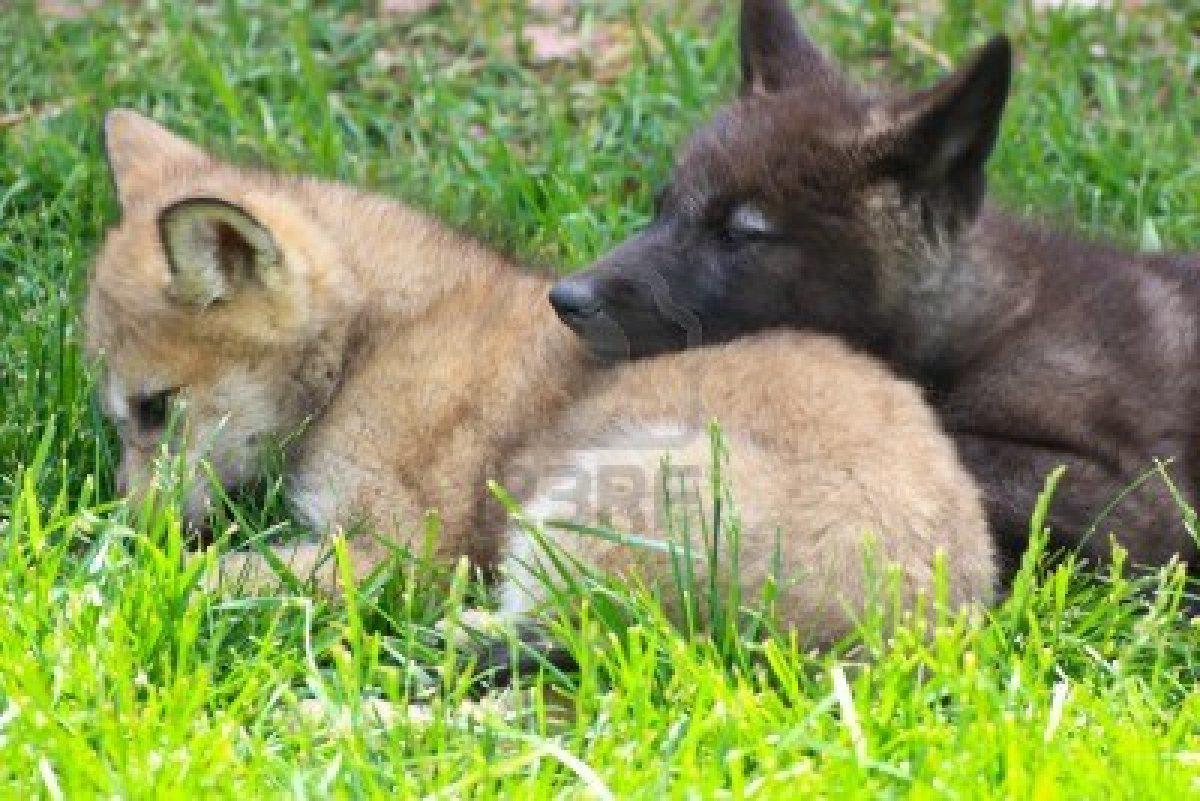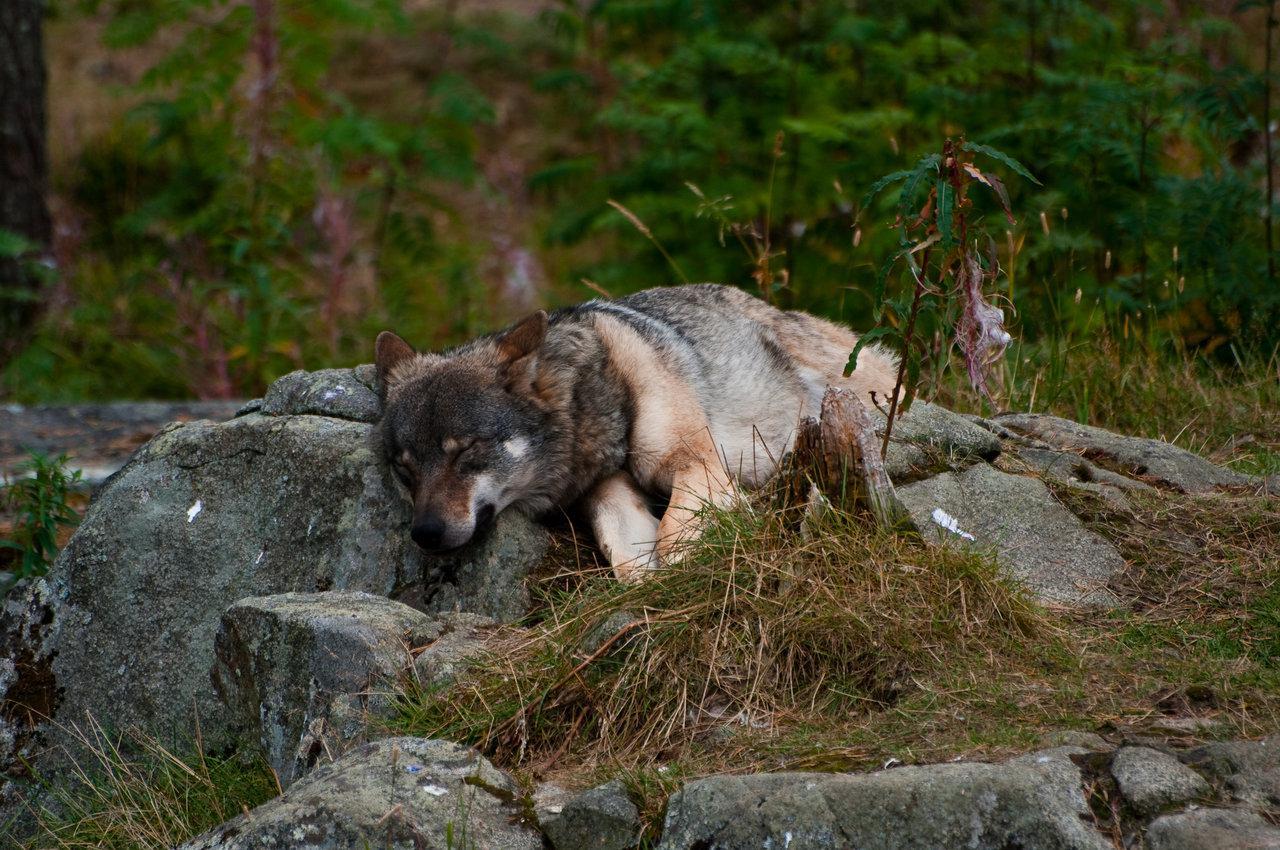The first image is the image on the left, the second image is the image on the right. Evaluate the accuracy of this statement regarding the images: "In the left image, two animals are laying down together.". Is it true? Answer yes or no. Yes. The first image is the image on the left, the second image is the image on the right. Assess this claim about the two images: "One animal is lying their head across the body of another animal.". Correct or not? Answer yes or no. Yes. 